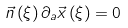<formula> <loc_0><loc_0><loc_500><loc_500>\vec { n } \left ( \xi \right ) \partial _ { a } \vec { x } \left ( \xi \right ) = 0</formula> 